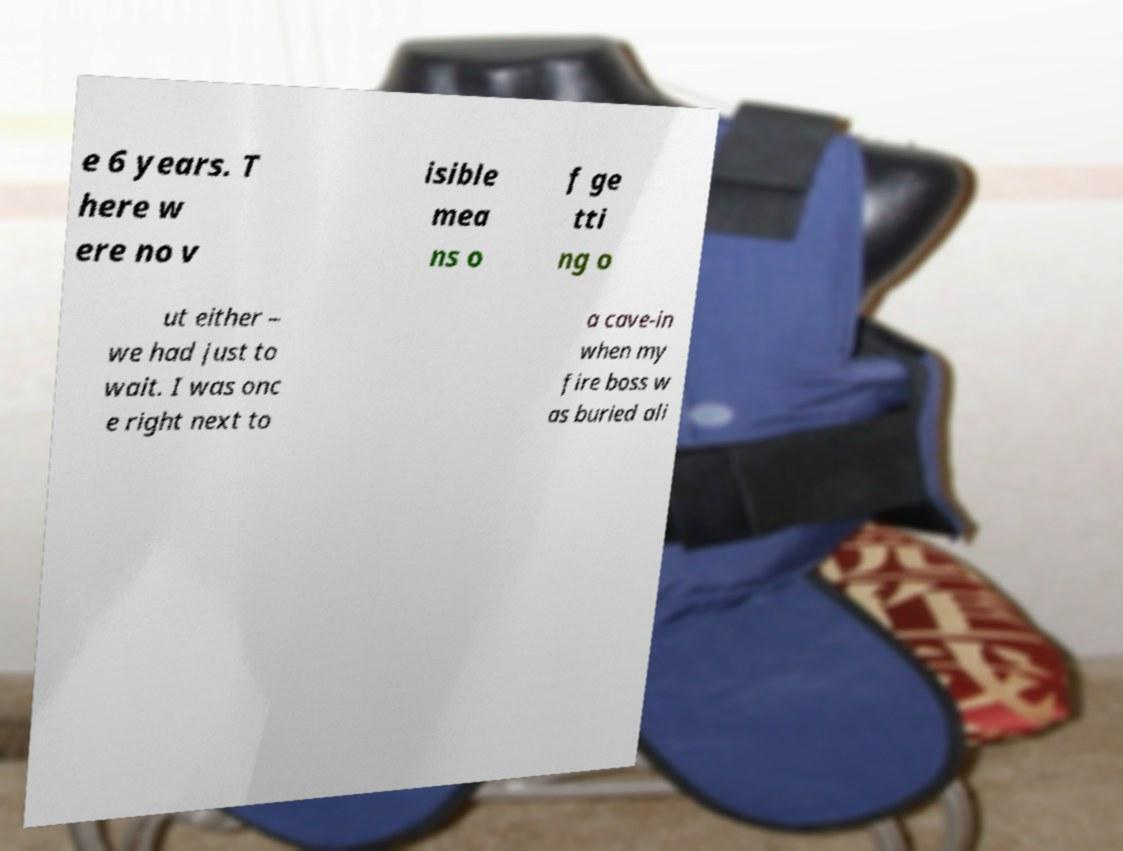Can you read and provide the text displayed in the image?This photo seems to have some interesting text. Can you extract and type it out for me? e 6 years. T here w ere no v isible mea ns o f ge tti ng o ut either – we had just to wait. I was onc e right next to a cave-in when my fire boss w as buried ali 